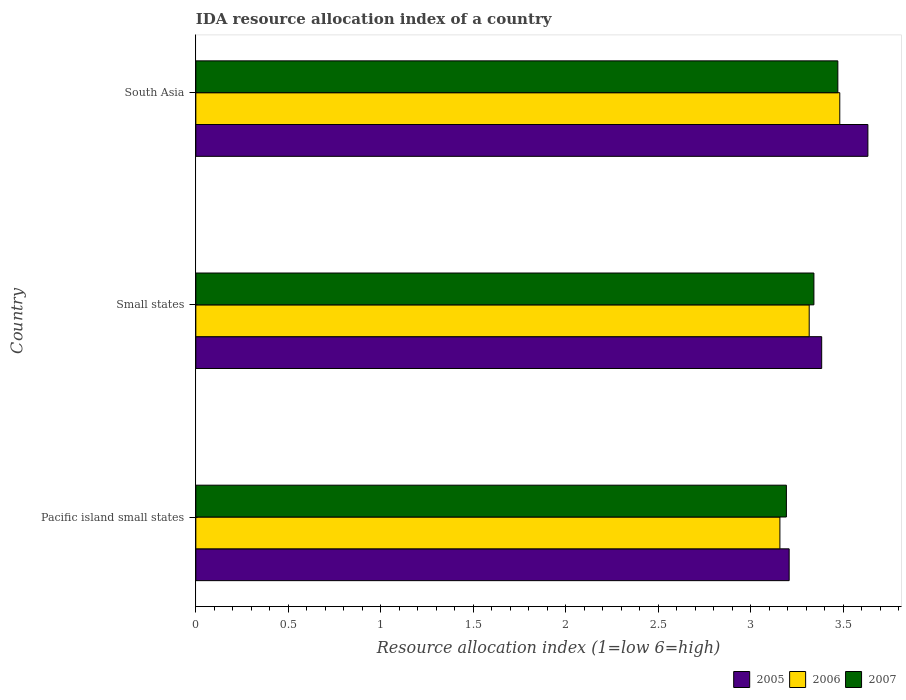Are the number of bars per tick equal to the number of legend labels?
Ensure brevity in your answer.  Yes. Are the number of bars on each tick of the Y-axis equal?
Offer a very short reply. Yes. How many bars are there on the 1st tick from the top?
Offer a terse response. 3. How many bars are there on the 2nd tick from the bottom?
Ensure brevity in your answer.  3. What is the label of the 2nd group of bars from the top?
Give a very brief answer. Small states. In how many cases, is the number of bars for a given country not equal to the number of legend labels?
Ensure brevity in your answer.  0. What is the IDA resource allocation index in 2005 in South Asia?
Ensure brevity in your answer.  3.63. Across all countries, what is the maximum IDA resource allocation index in 2007?
Provide a short and direct response. 3.47. Across all countries, what is the minimum IDA resource allocation index in 2005?
Your answer should be very brief. 3.21. In which country was the IDA resource allocation index in 2007 minimum?
Give a very brief answer. Pacific island small states. What is the total IDA resource allocation index in 2005 in the graph?
Provide a short and direct response. 10.22. What is the difference between the IDA resource allocation index in 2006 in Pacific island small states and that in Small states?
Provide a succinct answer. -0.16. What is the difference between the IDA resource allocation index in 2007 in Pacific island small states and the IDA resource allocation index in 2005 in South Asia?
Keep it short and to the point. -0.44. What is the average IDA resource allocation index in 2006 per country?
Give a very brief answer. 3.32. What is the difference between the IDA resource allocation index in 2006 and IDA resource allocation index in 2007 in South Asia?
Your response must be concise. 0.01. In how many countries, is the IDA resource allocation index in 2005 greater than 2.4 ?
Your answer should be compact. 3. What is the ratio of the IDA resource allocation index in 2005 in Pacific island small states to that in South Asia?
Make the answer very short. 0.88. Is the IDA resource allocation index in 2006 in Pacific island small states less than that in Small states?
Ensure brevity in your answer.  Yes. Is the difference between the IDA resource allocation index in 2006 in Pacific island small states and South Asia greater than the difference between the IDA resource allocation index in 2007 in Pacific island small states and South Asia?
Keep it short and to the point. No. What is the difference between the highest and the second highest IDA resource allocation index in 2007?
Provide a succinct answer. 0.13. What is the difference between the highest and the lowest IDA resource allocation index in 2005?
Ensure brevity in your answer.  0.43. In how many countries, is the IDA resource allocation index in 2006 greater than the average IDA resource allocation index in 2006 taken over all countries?
Offer a terse response. 1. Is the sum of the IDA resource allocation index in 2006 in Small states and South Asia greater than the maximum IDA resource allocation index in 2005 across all countries?
Provide a succinct answer. Yes. Is it the case that in every country, the sum of the IDA resource allocation index in 2007 and IDA resource allocation index in 2005 is greater than the IDA resource allocation index in 2006?
Provide a short and direct response. Yes. How many countries are there in the graph?
Ensure brevity in your answer.  3. Does the graph contain grids?
Your answer should be very brief. No. Where does the legend appear in the graph?
Your answer should be very brief. Bottom right. What is the title of the graph?
Offer a very short reply. IDA resource allocation index of a country. What is the label or title of the X-axis?
Offer a terse response. Resource allocation index (1=low 6=high). What is the label or title of the Y-axis?
Give a very brief answer. Country. What is the Resource allocation index (1=low 6=high) in 2005 in Pacific island small states?
Your answer should be compact. 3.21. What is the Resource allocation index (1=low 6=high) in 2006 in Pacific island small states?
Provide a succinct answer. 3.16. What is the Resource allocation index (1=low 6=high) of 2007 in Pacific island small states?
Your answer should be compact. 3.19. What is the Resource allocation index (1=low 6=high) in 2005 in Small states?
Offer a terse response. 3.38. What is the Resource allocation index (1=low 6=high) of 2006 in Small states?
Your response must be concise. 3.31. What is the Resource allocation index (1=low 6=high) in 2007 in Small states?
Give a very brief answer. 3.34. What is the Resource allocation index (1=low 6=high) of 2005 in South Asia?
Make the answer very short. 3.63. What is the Resource allocation index (1=low 6=high) of 2006 in South Asia?
Your answer should be compact. 3.48. What is the Resource allocation index (1=low 6=high) in 2007 in South Asia?
Make the answer very short. 3.47. Across all countries, what is the maximum Resource allocation index (1=low 6=high) of 2005?
Keep it short and to the point. 3.63. Across all countries, what is the maximum Resource allocation index (1=low 6=high) of 2006?
Your answer should be compact. 3.48. Across all countries, what is the maximum Resource allocation index (1=low 6=high) in 2007?
Give a very brief answer. 3.47. Across all countries, what is the minimum Resource allocation index (1=low 6=high) of 2005?
Provide a succinct answer. 3.21. Across all countries, what is the minimum Resource allocation index (1=low 6=high) of 2006?
Your response must be concise. 3.16. Across all countries, what is the minimum Resource allocation index (1=low 6=high) in 2007?
Provide a short and direct response. 3.19. What is the total Resource allocation index (1=low 6=high) of 2005 in the graph?
Make the answer very short. 10.22. What is the total Resource allocation index (1=low 6=high) of 2006 in the graph?
Keep it short and to the point. 9.95. What is the total Resource allocation index (1=low 6=high) of 2007 in the graph?
Ensure brevity in your answer.  10. What is the difference between the Resource allocation index (1=low 6=high) of 2005 in Pacific island small states and that in Small states?
Your response must be concise. -0.18. What is the difference between the Resource allocation index (1=low 6=high) of 2006 in Pacific island small states and that in Small states?
Provide a short and direct response. -0.16. What is the difference between the Resource allocation index (1=low 6=high) in 2007 in Pacific island small states and that in Small states?
Provide a succinct answer. -0.15. What is the difference between the Resource allocation index (1=low 6=high) of 2005 in Pacific island small states and that in South Asia?
Ensure brevity in your answer.  -0.43. What is the difference between the Resource allocation index (1=low 6=high) in 2006 in Pacific island small states and that in South Asia?
Offer a very short reply. -0.32. What is the difference between the Resource allocation index (1=low 6=high) of 2007 in Pacific island small states and that in South Asia?
Offer a very short reply. -0.28. What is the difference between the Resource allocation index (1=low 6=high) in 2005 in Small states and that in South Asia?
Keep it short and to the point. -0.25. What is the difference between the Resource allocation index (1=low 6=high) in 2006 in Small states and that in South Asia?
Give a very brief answer. -0.17. What is the difference between the Resource allocation index (1=low 6=high) in 2007 in Small states and that in South Asia?
Offer a terse response. -0.13. What is the difference between the Resource allocation index (1=low 6=high) of 2005 in Pacific island small states and the Resource allocation index (1=low 6=high) of 2006 in Small states?
Give a very brief answer. -0.11. What is the difference between the Resource allocation index (1=low 6=high) of 2005 in Pacific island small states and the Resource allocation index (1=low 6=high) of 2007 in Small states?
Provide a short and direct response. -0.13. What is the difference between the Resource allocation index (1=low 6=high) of 2006 in Pacific island small states and the Resource allocation index (1=low 6=high) of 2007 in Small states?
Make the answer very short. -0.18. What is the difference between the Resource allocation index (1=low 6=high) of 2005 in Pacific island small states and the Resource allocation index (1=low 6=high) of 2006 in South Asia?
Give a very brief answer. -0.27. What is the difference between the Resource allocation index (1=low 6=high) of 2005 in Pacific island small states and the Resource allocation index (1=low 6=high) of 2007 in South Asia?
Give a very brief answer. -0.26. What is the difference between the Resource allocation index (1=low 6=high) of 2006 in Pacific island small states and the Resource allocation index (1=low 6=high) of 2007 in South Asia?
Provide a succinct answer. -0.31. What is the difference between the Resource allocation index (1=low 6=high) in 2005 in Small states and the Resource allocation index (1=low 6=high) in 2006 in South Asia?
Keep it short and to the point. -0.1. What is the difference between the Resource allocation index (1=low 6=high) in 2005 in Small states and the Resource allocation index (1=low 6=high) in 2007 in South Asia?
Ensure brevity in your answer.  -0.09. What is the difference between the Resource allocation index (1=low 6=high) of 2006 in Small states and the Resource allocation index (1=low 6=high) of 2007 in South Asia?
Provide a succinct answer. -0.15. What is the average Resource allocation index (1=low 6=high) of 2005 per country?
Keep it short and to the point. 3.41. What is the average Resource allocation index (1=low 6=high) in 2006 per country?
Offer a very short reply. 3.32. What is the average Resource allocation index (1=low 6=high) of 2007 per country?
Keep it short and to the point. 3.33. What is the difference between the Resource allocation index (1=low 6=high) in 2005 and Resource allocation index (1=low 6=high) in 2006 in Pacific island small states?
Offer a very short reply. 0.05. What is the difference between the Resource allocation index (1=low 6=high) in 2005 and Resource allocation index (1=low 6=high) in 2007 in Pacific island small states?
Provide a succinct answer. 0.01. What is the difference between the Resource allocation index (1=low 6=high) in 2006 and Resource allocation index (1=low 6=high) in 2007 in Pacific island small states?
Offer a terse response. -0.04. What is the difference between the Resource allocation index (1=low 6=high) of 2005 and Resource allocation index (1=low 6=high) of 2006 in Small states?
Offer a very short reply. 0.07. What is the difference between the Resource allocation index (1=low 6=high) in 2005 and Resource allocation index (1=low 6=high) in 2007 in Small states?
Your response must be concise. 0.04. What is the difference between the Resource allocation index (1=low 6=high) in 2006 and Resource allocation index (1=low 6=high) in 2007 in Small states?
Keep it short and to the point. -0.03. What is the difference between the Resource allocation index (1=low 6=high) of 2005 and Resource allocation index (1=low 6=high) of 2006 in South Asia?
Your answer should be compact. 0.15. What is the difference between the Resource allocation index (1=low 6=high) of 2005 and Resource allocation index (1=low 6=high) of 2007 in South Asia?
Keep it short and to the point. 0.16. What is the difference between the Resource allocation index (1=low 6=high) of 2006 and Resource allocation index (1=low 6=high) of 2007 in South Asia?
Offer a terse response. 0.01. What is the ratio of the Resource allocation index (1=low 6=high) of 2005 in Pacific island small states to that in Small states?
Your response must be concise. 0.95. What is the ratio of the Resource allocation index (1=low 6=high) in 2006 in Pacific island small states to that in Small states?
Ensure brevity in your answer.  0.95. What is the ratio of the Resource allocation index (1=low 6=high) in 2007 in Pacific island small states to that in Small states?
Offer a terse response. 0.96. What is the ratio of the Resource allocation index (1=low 6=high) of 2005 in Pacific island small states to that in South Asia?
Make the answer very short. 0.88. What is the ratio of the Resource allocation index (1=low 6=high) of 2006 in Pacific island small states to that in South Asia?
Offer a terse response. 0.91. What is the ratio of the Resource allocation index (1=low 6=high) of 2007 in Pacific island small states to that in South Asia?
Provide a short and direct response. 0.92. What is the ratio of the Resource allocation index (1=low 6=high) of 2005 in Small states to that in South Asia?
Offer a very short reply. 0.93. What is the ratio of the Resource allocation index (1=low 6=high) in 2006 in Small states to that in South Asia?
Your answer should be very brief. 0.95. What is the ratio of the Resource allocation index (1=low 6=high) in 2007 in Small states to that in South Asia?
Provide a short and direct response. 0.96. What is the difference between the highest and the second highest Resource allocation index (1=low 6=high) in 2005?
Offer a terse response. 0.25. What is the difference between the highest and the second highest Resource allocation index (1=low 6=high) of 2006?
Offer a terse response. 0.17. What is the difference between the highest and the second highest Resource allocation index (1=low 6=high) in 2007?
Keep it short and to the point. 0.13. What is the difference between the highest and the lowest Resource allocation index (1=low 6=high) of 2005?
Ensure brevity in your answer.  0.43. What is the difference between the highest and the lowest Resource allocation index (1=low 6=high) in 2006?
Ensure brevity in your answer.  0.32. What is the difference between the highest and the lowest Resource allocation index (1=low 6=high) in 2007?
Make the answer very short. 0.28. 